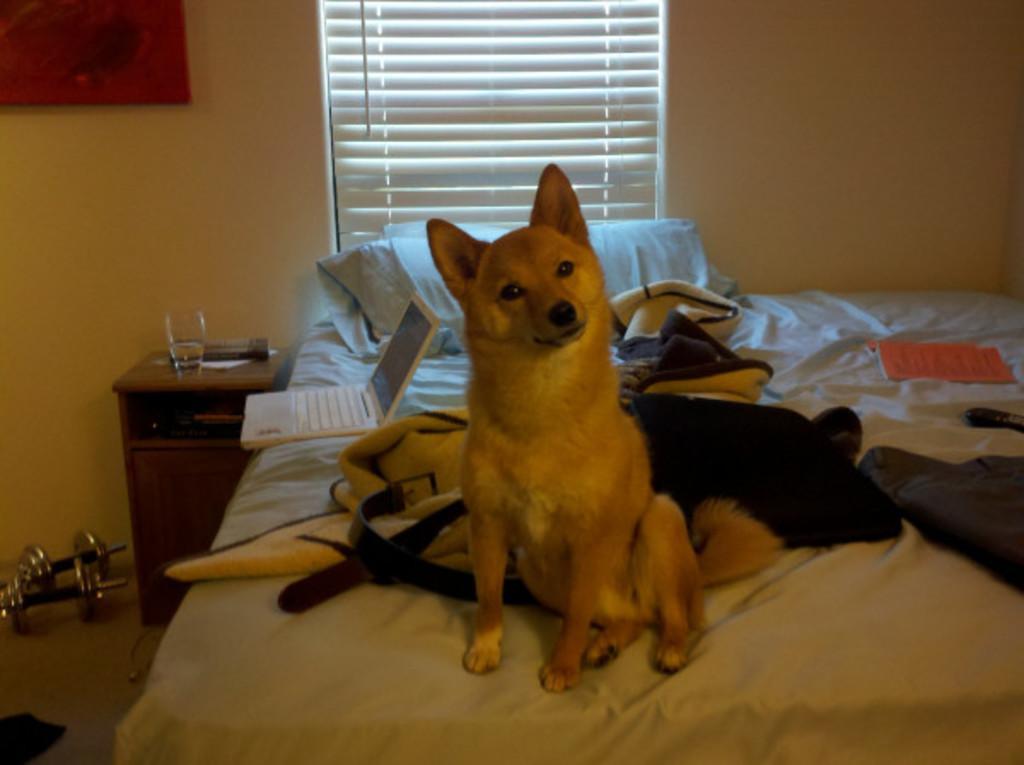In one or two sentences, can you explain what this image depicts? In this image there is a dog sitting on the bed and there are objects on the bed, there is a laptop and there is a book and there is a pillow. On the left side there is a table, on the table there is a glass and there are objects which are white and black in colour and on the ground there are metal objects. In the background there is a window and there is a frame on the wall and in the front on the left side there is an object which is black in colour. 